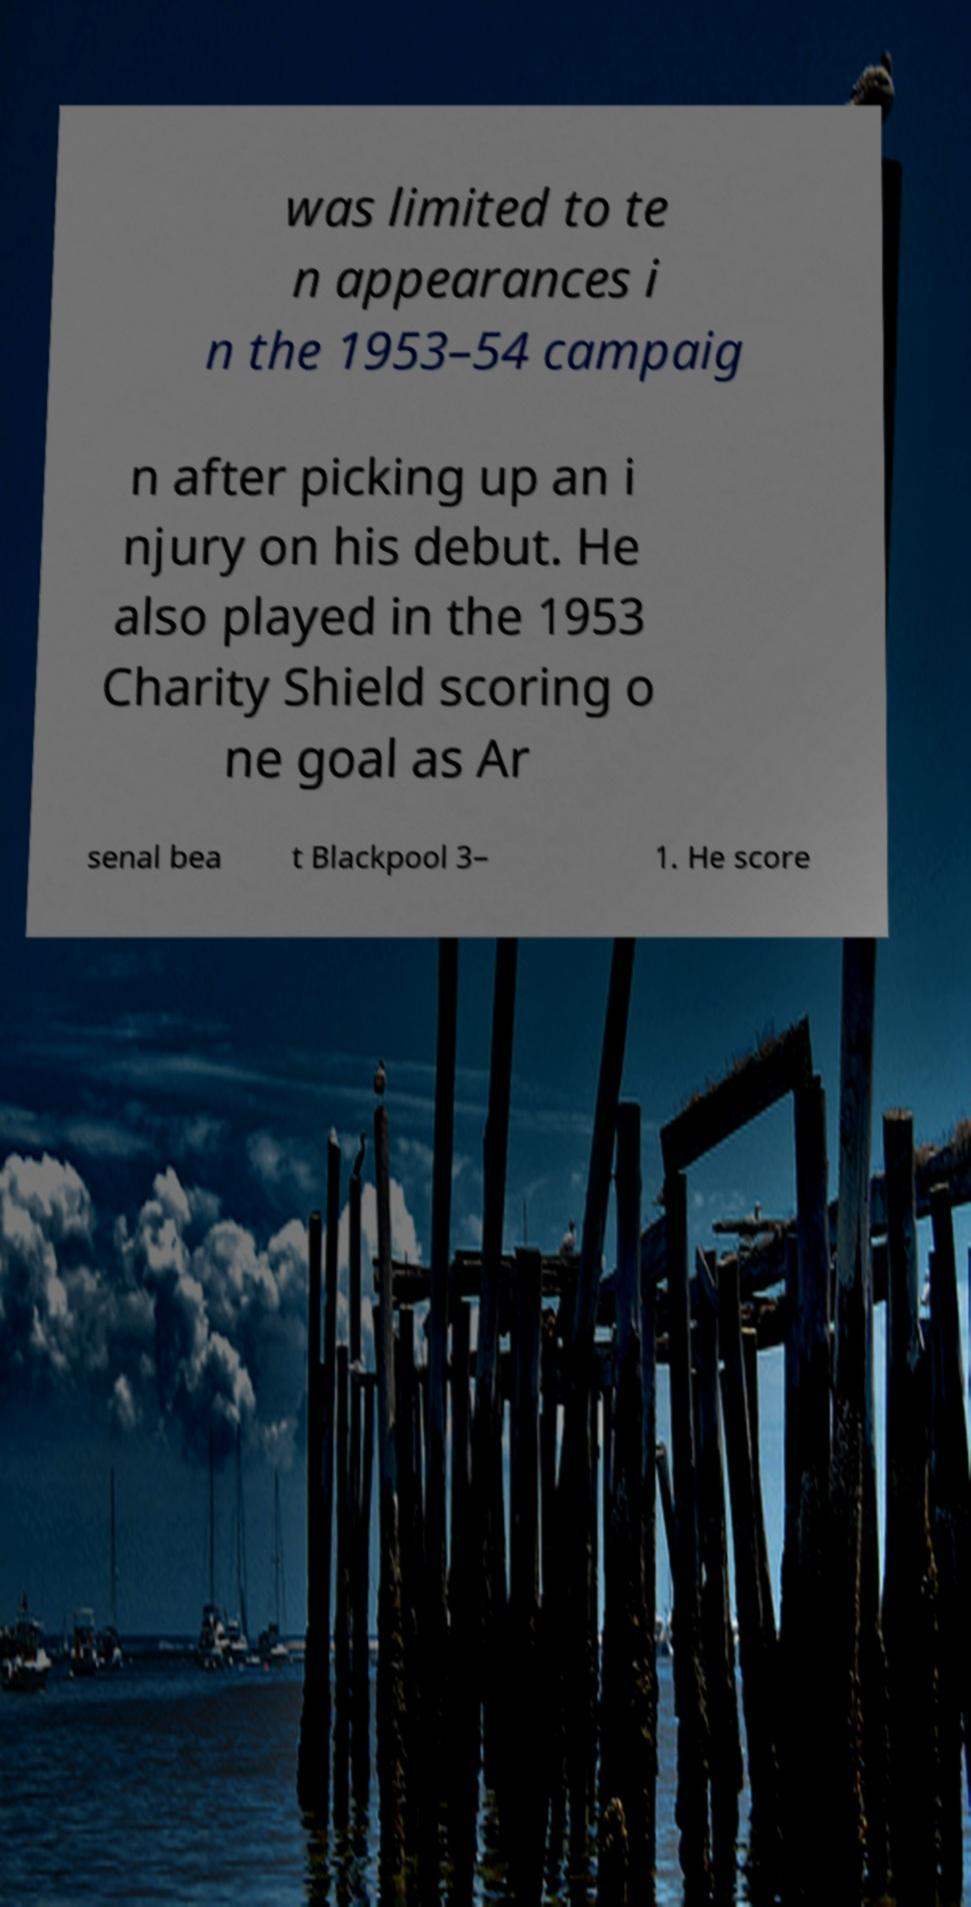Could you extract and type out the text from this image? was limited to te n appearances i n the 1953–54 campaig n after picking up an i njury on his debut. He also played in the 1953 Charity Shield scoring o ne goal as Ar senal bea t Blackpool 3– 1. He score 